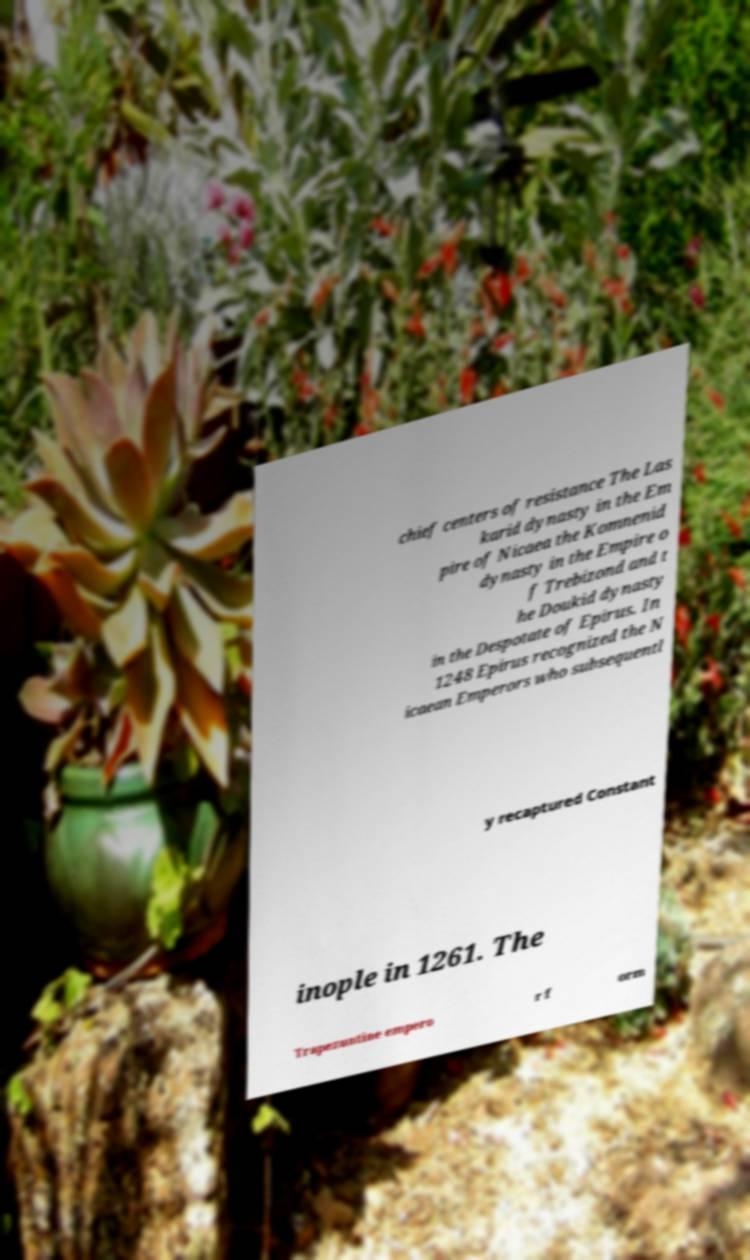For documentation purposes, I need the text within this image transcribed. Could you provide that? chief centers of resistance The Las karid dynasty in the Em pire of Nicaea the Komnenid dynasty in the Empire o f Trebizond and t he Doukid dynasty in the Despotate of Epirus. In 1248 Epirus recognized the N icaean Emperors who subsequentl y recaptured Constant inople in 1261. The Trapezuntine empero r f orm 